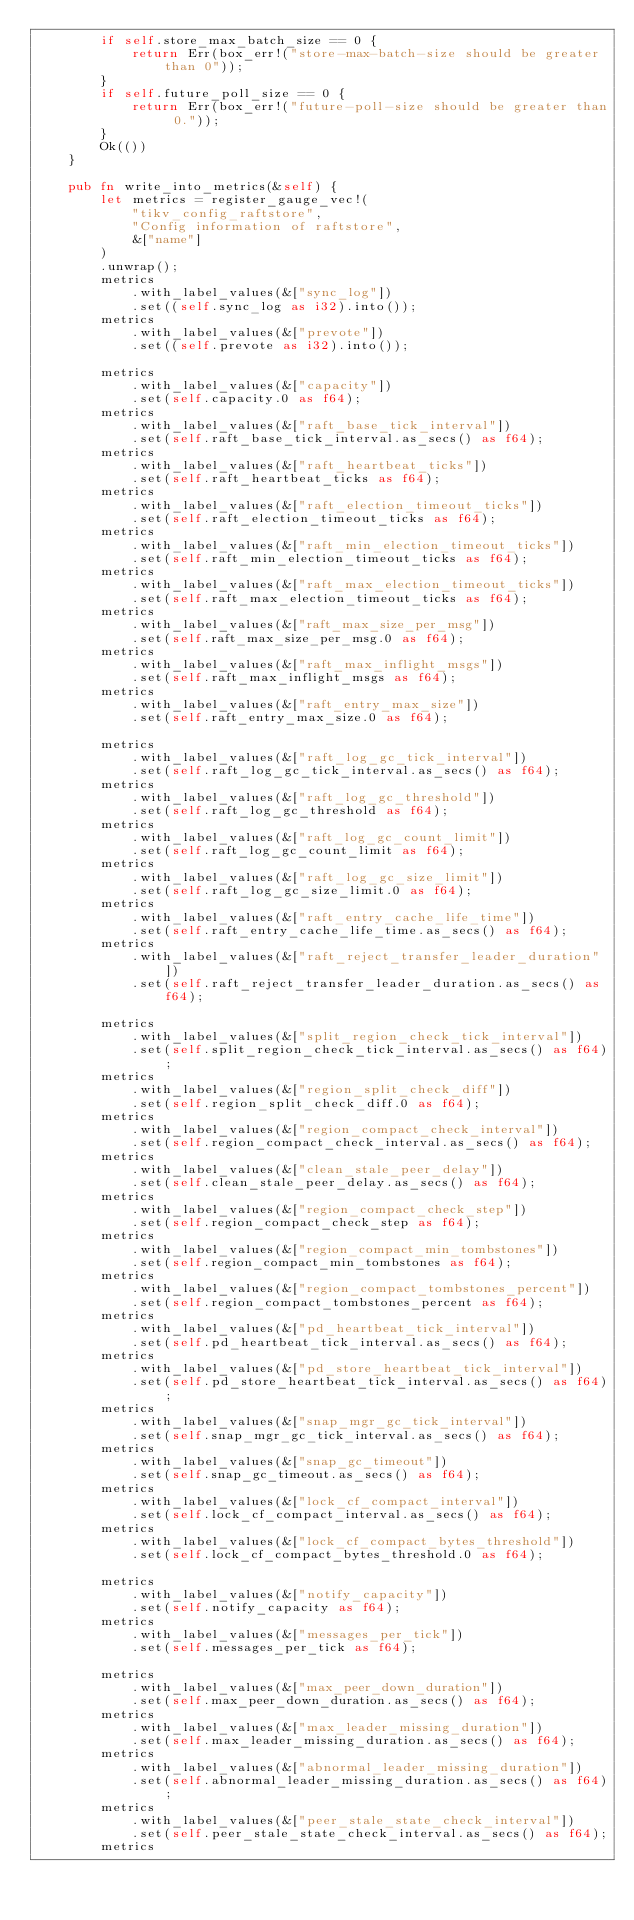Convert code to text. <code><loc_0><loc_0><loc_500><loc_500><_Rust_>        if self.store_max_batch_size == 0 {
            return Err(box_err!("store-max-batch-size should be greater than 0"));
        }
        if self.future_poll_size == 0 {
            return Err(box_err!("future-poll-size should be greater than 0."));
        }
        Ok(())
    }

    pub fn write_into_metrics(&self) {
        let metrics = register_gauge_vec!(
            "tikv_config_raftstore",
            "Config information of raftstore",
            &["name"]
        )
        .unwrap();
        metrics
            .with_label_values(&["sync_log"])
            .set((self.sync_log as i32).into());
        metrics
            .with_label_values(&["prevote"])
            .set((self.prevote as i32).into());

        metrics
            .with_label_values(&["capacity"])
            .set(self.capacity.0 as f64);
        metrics
            .with_label_values(&["raft_base_tick_interval"])
            .set(self.raft_base_tick_interval.as_secs() as f64);
        metrics
            .with_label_values(&["raft_heartbeat_ticks"])
            .set(self.raft_heartbeat_ticks as f64);
        metrics
            .with_label_values(&["raft_election_timeout_ticks"])
            .set(self.raft_election_timeout_ticks as f64);
        metrics
            .with_label_values(&["raft_min_election_timeout_ticks"])
            .set(self.raft_min_election_timeout_ticks as f64);
        metrics
            .with_label_values(&["raft_max_election_timeout_ticks"])
            .set(self.raft_max_election_timeout_ticks as f64);
        metrics
            .with_label_values(&["raft_max_size_per_msg"])
            .set(self.raft_max_size_per_msg.0 as f64);
        metrics
            .with_label_values(&["raft_max_inflight_msgs"])
            .set(self.raft_max_inflight_msgs as f64);
        metrics
            .with_label_values(&["raft_entry_max_size"])
            .set(self.raft_entry_max_size.0 as f64);

        metrics
            .with_label_values(&["raft_log_gc_tick_interval"])
            .set(self.raft_log_gc_tick_interval.as_secs() as f64);
        metrics
            .with_label_values(&["raft_log_gc_threshold"])
            .set(self.raft_log_gc_threshold as f64);
        metrics
            .with_label_values(&["raft_log_gc_count_limit"])
            .set(self.raft_log_gc_count_limit as f64);
        metrics
            .with_label_values(&["raft_log_gc_size_limit"])
            .set(self.raft_log_gc_size_limit.0 as f64);
        metrics
            .with_label_values(&["raft_entry_cache_life_time"])
            .set(self.raft_entry_cache_life_time.as_secs() as f64);
        metrics
            .with_label_values(&["raft_reject_transfer_leader_duration"])
            .set(self.raft_reject_transfer_leader_duration.as_secs() as f64);

        metrics
            .with_label_values(&["split_region_check_tick_interval"])
            .set(self.split_region_check_tick_interval.as_secs() as f64);
        metrics
            .with_label_values(&["region_split_check_diff"])
            .set(self.region_split_check_diff.0 as f64);
        metrics
            .with_label_values(&["region_compact_check_interval"])
            .set(self.region_compact_check_interval.as_secs() as f64);
        metrics
            .with_label_values(&["clean_stale_peer_delay"])
            .set(self.clean_stale_peer_delay.as_secs() as f64);
        metrics
            .with_label_values(&["region_compact_check_step"])
            .set(self.region_compact_check_step as f64);
        metrics
            .with_label_values(&["region_compact_min_tombstones"])
            .set(self.region_compact_min_tombstones as f64);
        metrics
            .with_label_values(&["region_compact_tombstones_percent"])
            .set(self.region_compact_tombstones_percent as f64);
        metrics
            .with_label_values(&["pd_heartbeat_tick_interval"])
            .set(self.pd_heartbeat_tick_interval.as_secs() as f64);
        metrics
            .with_label_values(&["pd_store_heartbeat_tick_interval"])
            .set(self.pd_store_heartbeat_tick_interval.as_secs() as f64);
        metrics
            .with_label_values(&["snap_mgr_gc_tick_interval"])
            .set(self.snap_mgr_gc_tick_interval.as_secs() as f64);
        metrics
            .with_label_values(&["snap_gc_timeout"])
            .set(self.snap_gc_timeout.as_secs() as f64);
        metrics
            .with_label_values(&["lock_cf_compact_interval"])
            .set(self.lock_cf_compact_interval.as_secs() as f64);
        metrics
            .with_label_values(&["lock_cf_compact_bytes_threshold"])
            .set(self.lock_cf_compact_bytes_threshold.0 as f64);

        metrics
            .with_label_values(&["notify_capacity"])
            .set(self.notify_capacity as f64);
        metrics
            .with_label_values(&["messages_per_tick"])
            .set(self.messages_per_tick as f64);

        metrics
            .with_label_values(&["max_peer_down_duration"])
            .set(self.max_peer_down_duration.as_secs() as f64);
        metrics
            .with_label_values(&["max_leader_missing_duration"])
            .set(self.max_leader_missing_duration.as_secs() as f64);
        metrics
            .with_label_values(&["abnormal_leader_missing_duration"])
            .set(self.abnormal_leader_missing_duration.as_secs() as f64);
        metrics
            .with_label_values(&["peer_stale_state_check_interval"])
            .set(self.peer_stale_state_check_interval.as_secs() as f64);
        metrics</code> 